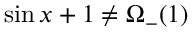Convert formula to latex. <formula><loc_0><loc_0><loc_500><loc_500>\sin x + 1 \not = \Omega _ { - } ( 1 )</formula> 